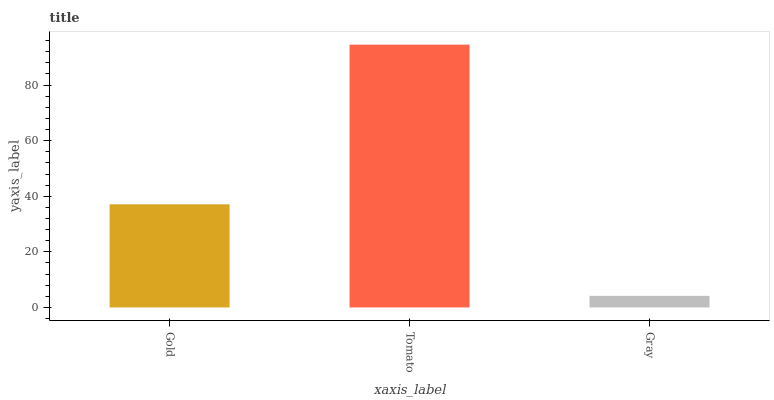Is Gray the minimum?
Answer yes or no. Yes. Is Tomato the maximum?
Answer yes or no. Yes. Is Tomato the minimum?
Answer yes or no. No. Is Gray the maximum?
Answer yes or no. No. Is Tomato greater than Gray?
Answer yes or no. Yes. Is Gray less than Tomato?
Answer yes or no. Yes. Is Gray greater than Tomato?
Answer yes or no. No. Is Tomato less than Gray?
Answer yes or no. No. Is Gold the high median?
Answer yes or no. Yes. Is Gold the low median?
Answer yes or no. Yes. Is Tomato the high median?
Answer yes or no. No. Is Gray the low median?
Answer yes or no. No. 